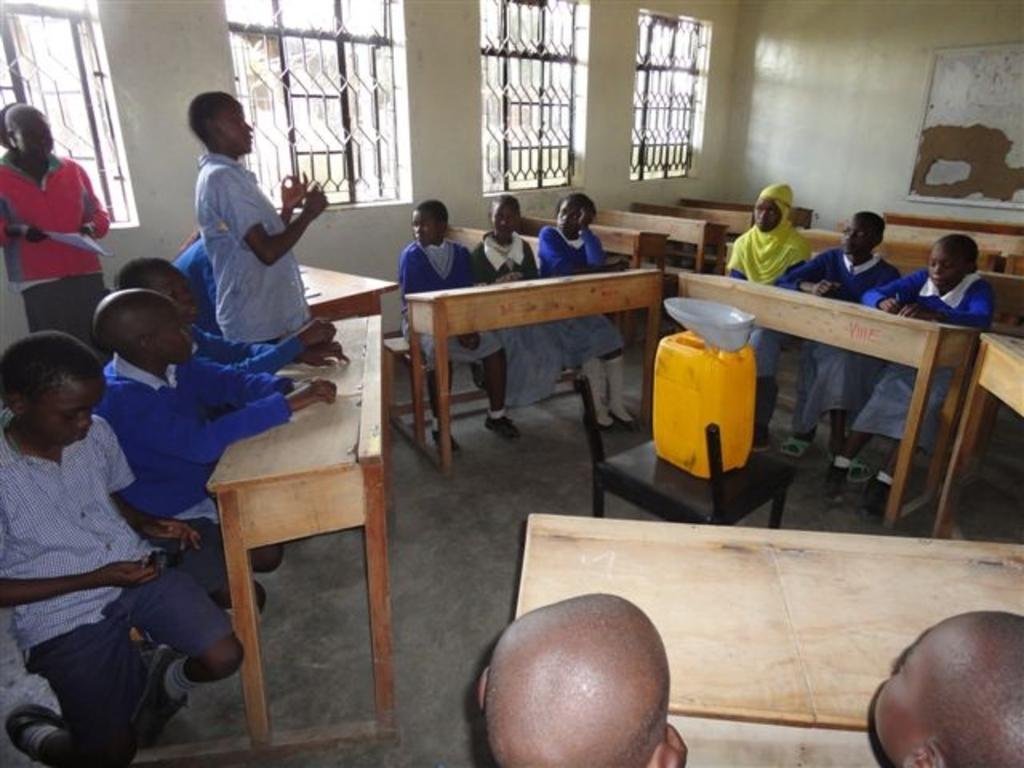Describe this image in one or two sentences. The picture is taken in a room. In the picture there are benches, chair, can, students sitting in benches. On the left there is a person standing. The background there are windows, outside the windows there are trees. 